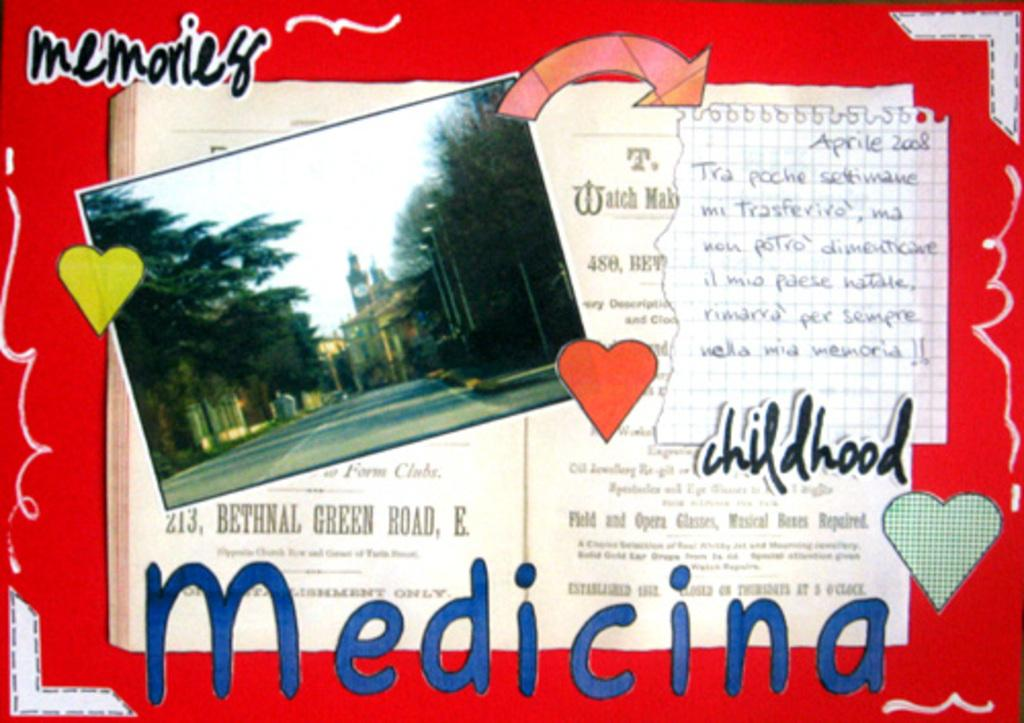<image>
Offer a succinct explanation of the picture presented. A book is open to a page labeled memories. 